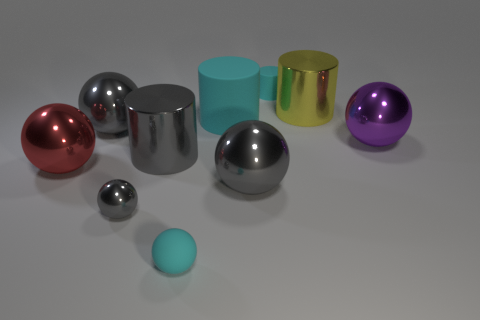Does the metal cylinder on the right side of the cyan sphere have the same size as the big red object?
Give a very brief answer. Yes. What is the tiny cyan thing that is behind the small gray metal object made of?
Offer a very short reply. Rubber. Is the number of large yellow shiny cylinders to the left of the purple metallic ball the same as the number of big red shiny balls to the left of the yellow cylinder?
Your answer should be very brief. Yes. There is a small rubber thing that is the same shape as the big red thing; what is its color?
Offer a terse response. Cyan. Is there anything else of the same color as the small rubber sphere?
Offer a terse response. Yes. What number of metal things are tiny gray things or big gray things?
Keep it short and to the point. 4. Does the tiny matte sphere have the same color as the tiny shiny ball?
Offer a terse response. No. Are there more large red objects behind the large red metallic ball than large gray metal cubes?
Your answer should be compact. No. What number of other objects are the same material as the red thing?
Your response must be concise. 6. How many small objects are either yellow cylinders or rubber things?
Your answer should be compact. 2. 